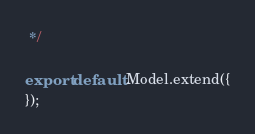<code> <loc_0><loc_0><loc_500><loc_500><_JavaScript_> */

export default Model.extend({
});
</code> 